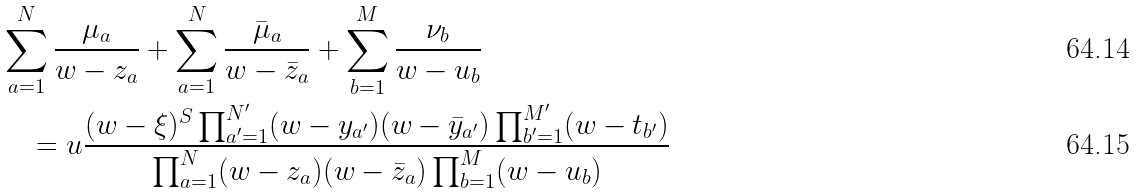<formula> <loc_0><loc_0><loc_500><loc_500>& \sum _ { a = 1 } ^ { N } \frac { \mu _ { a } } { w - z _ { a } } + \sum _ { a = 1 } ^ { N } \frac { \bar { \mu } _ { a } } { w - \bar { z } _ { a } } + \sum _ { b = 1 } ^ { M } \frac { \nu _ { b } } { w - u _ { b } } \\ & \quad = u \frac { ( w - \xi ) ^ { S } \prod _ { a ^ { \prime } = 1 } ^ { N ^ { \prime } } ( w - y _ { a ^ { \prime } } ) ( w - \bar { y } _ { a ^ { \prime } } ) \prod _ { b ^ { \prime } = 1 } ^ { M ^ { \prime } } ( w - t _ { b ^ { \prime } } ) } { \prod _ { a = 1 } ^ { N } ( w - z _ { a } ) ( w - \bar { z } _ { a } ) \prod _ { b = 1 } ^ { M } ( w - u _ { b } ) }</formula> 